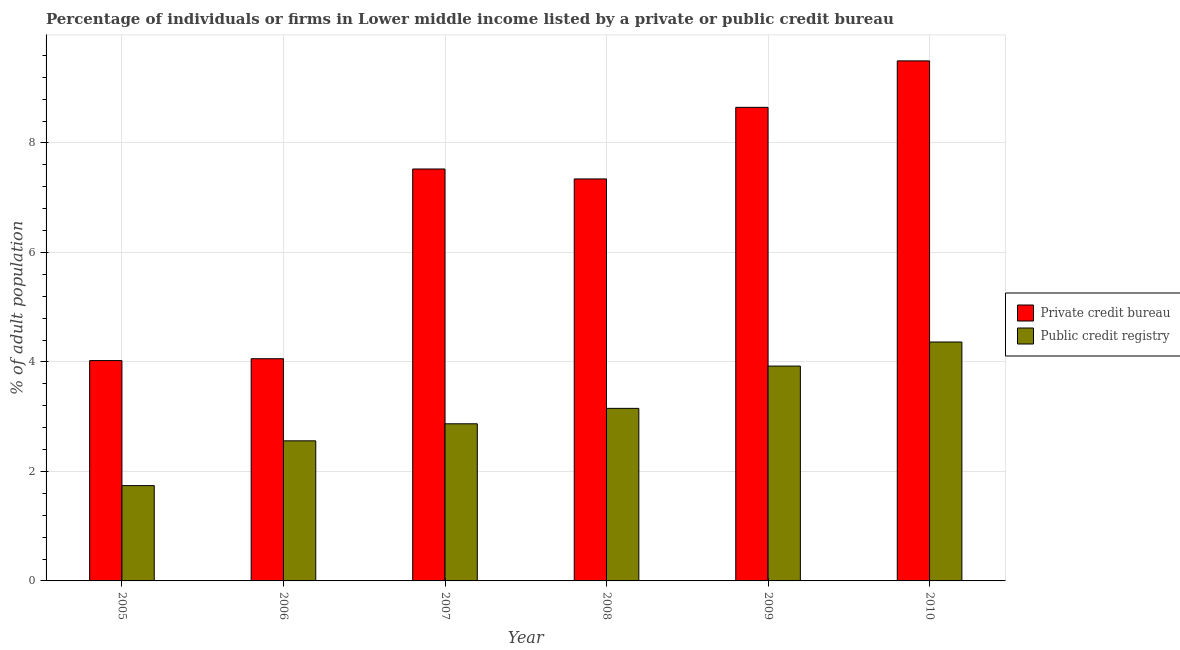How many different coloured bars are there?
Give a very brief answer. 2. How many groups of bars are there?
Your answer should be compact. 6. Are the number of bars per tick equal to the number of legend labels?
Keep it short and to the point. Yes. Are the number of bars on each tick of the X-axis equal?
Provide a succinct answer. Yes. How many bars are there on the 1st tick from the right?
Provide a succinct answer. 2. In how many cases, is the number of bars for a given year not equal to the number of legend labels?
Keep it short and to the point. 0. What is the percentage of firms listed by private credit bureau in 2009?
Your answer should be compact. 8.65. Across all years, what is the minimum percentage of firms listed by public credit bureau?
Provide a succinct answer. 1.74. In which year was the percentage of firms listed by public credit bureau minimum?
Offer a very short reply. 2005. What is the total percentage of firms listed by private credit bureau in the graph?
Provide a short and direct response. 41.1. What is the difference between the percentage of firms listed by private credit bureau in 2006 and that in 2009?
Offer a terse response. -4.59. What is the difference between the percentage of firms listed by private credit bureau in 2009 and the percentage of firms listed by public credit bureau in 2007?
Provide a short and direct response. 1.13. What is the average percentage of firms listed by public credit bureau per year?
Give a very brief answer. 3.1. What is the ratio of the percentage of firms listed by public credit bureau in 2005 to that in 2006?
Offer a terse response. 0.68. Is the percentage of firms listed by private credit bureau in 2005 less than that in 2010?
Keep it short and to the point. Yes. What is the difference between the highest and the second highest percentage of firms listed by private credit bureau?
Your response must be concise. 0.85. What is the difference between the highest and the lowest percentage of firms listed by private credit bureau?
Offer a very short reply. 5.47. Is the sum of the percentage of firms listed by public credit bureau in 2007 and 2008 greater than the maximum percentage of firms listed by private credit bureau across all years?
Offer a terse response. Yes. What does the 2nd bar from the left in 2008 represents?
Your answer should be very brief. Public credit registry. What does the 2nd bar from the right in 2009 represents?
Provide a short and direct response. Private credit bureau. How many bars are there?
Make the answer very short. 12. Are all the bars in the graph horizontal?
Provide a succinct answer. No. What is the difference between two consecutive major ticks on the Y-axis?
Provide a succinct answer. 2. Does the graph contain any zero values?
Offer a terse response. No. Where does the legend appear in the graph?
Your answer should be compact. Center right. How many legend labels are there?
Make the answer very short. 2. How are the legend labels stacked?
Provide a succinct answer. Vertical. What is the title of the graph?
Ensure brevity in your answer.  Percentage of individuals or firms in Lower middle income listed by a private or public credit bureau. What is the label or title of the X-axis?
Your answer should be very brief. Year. What is the label or title of the Y-axis?
Give a very brief answer. % of adult population. What is the % of adult population in Private credit bureau in 2005?
Make the answer very short. 4.03. What is the % of adult population in Public credit registry in 2005?
Your response must be concise. 1.74. What is the % of adult population of Private credit bureau in 2006?
Your answer should be very brief. 4.06. What is the % of adult population in Public credit registry in 2006?
Provide a succinct answer. 2.56. What is the % of adult population of Private credit bureau in 2007?
Provide a succinct answer. 7.53. What is the % of adult population of Public credit registry in 2007?
Offer a terse response. 2.87. What is the % of adult population of Private credit bureau in 2008?
Give a very brief answer. 7.34. What is the % of adult population in Public credit registry in 2008?
Offer a very short reply. 3.15. What is the % of adult population of Private credit bureau in 2009?
Make the answer very short. 8.65. What is the % of adult population in Public credit registry in 2009?
Your response must be concise. 3.92. What is the % of adult population of Private credit bureau in 2010?
Offer a very short reply. 9.5. What is the % of adult population of Public credit registry in 2010?
Give a very brief answer. 4.36. Across all years, what is the maximum % of adult population in Public credit registry?
Offer a very short reply. 4.36. Across all years, what is the minimum % of adult population in Private credit bureau?
Ensure brevity in your answer.  4.03. Across all years, what is the minimum % of adult population in Public credit registry?
Ensure brevity in your answer.  1.74. What is the total % of adult population in Private credit bureau in the graph?
Provide a short and direct response. 41.1. What is the total % of adult population in Public credit registry in the graph?
Your response must be concise. 18.61. What is the difference between the % of adult population in Private credit bureau in 2005 and that in 2006?
Your answer should be very brief. -0.03. What is the difference between the % of adult population in Public credit registry in 2005 and that in 2006?
Your response must be concise. -0.82. What is the difference between the % of adult population in Private credit bureau in 2005 and that in 2007?
Your response must be concise. -3.5. What is the difference between the % of adult population in Public credit registry in 2005 and that in 2007?
Provide a succinct answer. -1.13. What is the difference between the % of adult population of Private credit bureau in 2005 and that in 2008?
Offer a terse response. -3.32. What is the difference between the % of adult population in Public credit registry in 2005 and that in 2008?
Make the answer very short. -1.41. What is the difference between the % of adult population of Private credit bureau in 2005 and that in 2009?
Provide a short and direct response. -4.63. What is the difference between the % of adult population in Public credit registry in 2005 and that in 2009?
Offer a terse response. -2.18. What is the difference between the % of adult population in Private credit bureau in 2005 and that in 2010?
Ensure brevity in your answer.  -5.47. What is the difference between the % of adult population of Public credit registry in 2005 and that in 2010?
Your answer should be compact. -2.62. What is the difference between the % of adult population in Private credit bureau in 2006 and that in 2007?
Your answer should be very brief. -3.47. What is the difference between the % of adult population of Public credit registry in 2006 and that in 2007?
Offer a terse response. -0.31. What is the difference between the % of adult population in Private credit bureau in 2006 and that in 2008?
Your answer should be very brief. -3.28. What is the difference between the % of adult population of Public credit registry in 2006 and that in 2008?
Your response must be concise. -0.59. What is the difference between the % of adult population in Private credit bureau in 2006 and that in 2009?
Your answer should be very brief. -4.59. What is the difference between the % of adult population in Public credit registry in 2006 and that in 2009?
Your answer should be compact. -1.37. What is the difference between the % of adult population of Private credit bureau in 2006 and that in 2010?
Provide a succinct answer. -5.44. What is the difference between the % of adult population of Public credit registry in 2006 and that in 2010?
Make the answer very short. -1.81. What is the difference between the % of adult population in Private credit bureau in 2007 and that in 2008?
Ensure brevity in your answer.  0.18. What is the difference between the % of adult population in Public credit registry in 2007 and that in 2008?
Make the answer very short. -0.28. What is the difference between the % of adult population in Private credit bureau in 2007 and that in 2009?
Provide a short and direct response. -1.13. What is the difference between the % of adult population in Public credit registry in 2007 and that in 2009?
Make the answer very short. -1.05. What is the difference between the % of adult population in Private credit bureau in 2007 and that in 2010?
Ensure brevity in your answer.  -1.98. What is the difference between the % of adult population of Public credit registry in 2007 and that in 2010?
Ensure brevity in your answer.  -1.49. What is the difference between the % of adult population in Private credit bureau in 2008 and that in 2009?
Your response must be concise. -1.31. What is the difference between the % of adult population in Public credit registry in 2008 and that in 2009?
Offer a very short reply. -0.77. What is the difference between the % of adult population in Private credit bureau in 2008 and that in 2010?
Make the answer very short. -2.16. What is the difference between the % of adult population in Public credit registry in 2008 and that in 2010?
Offer a very short reply. -1.21. What is the difference between the % of adult population in Private credit bureau in 2009 and that in 2010?
Make the answer very short. -0.85. What is the difference between the % of adult population in Public credit registry in 2009 and that in 2010?
Your answer should be very brief. -0.44. What is the difference between the % of adult population in Private credit bureau in 2005 and the % of adult population in Public credit registry in 2006?
Your answer should be very brief. 1.47. What is the difference between the % of adult population in Private credit bureau in 2005 and the % of adult population in Public credit registry in 2007?
Provide a succinct answer. 1.15. What is the difference between the % of adult population of Private credit bureau in 2005 and the % of adult population of Public credit registry in 2008?
Provide a succinct answer. 0.87. What is the difference between the % of adult population of Private credit bureau in 2005 and the % of adult population of Public credit registry in 2009?
Your answer should be very brief. 0.1. What is the difference between the % of adult population in Private credit bureau in 2005 and the % of adult population in Public credit registry in 2010?
Your answer should be very brief. -0.34. What is the difference between the % of adult population of Private credit bureau in 2006 and the % of adult population of Public credit registry in 2007?
Provide a short and direct response. 1.19. What is the difference between the % of adult population in Private credit bureau in 2006 and the % of adult population in Public credit registry in 2008?
Your answer should be very brief. 0.91. What is the difference between the % of adult population in Private credit bureau in 2006 and the % of adult population in Public credit registry in 2009?
Keep it short and to the point. 0.13. What is the difference between the % of adult population of Private credit bureau in 2006 and the % of adult population of Public credit registry in 2010?
Make the answer very short. -0.31. What is the difference between the % of adult population of Private credit bureau in 2007 and the % of adult population of Public credit registry in 2008?
Your answer should be very brief. 4.37. What is the difference between the % of adult population of Private credit bureau in 2007 and the % of adult population of Public credit registry in 2009?
Provide a short and direct response. 3.6. What is the difference between the % of adult population in Private credit bureau in 2007 and the % of adult population in Public credit registry in 2010?
Ensure brevity in your answer.  3.16. What is the difference between the % of adult population of Private credit bureau in 2008 and the % of adult population of Public credit registry in 2009?
Give a very brief answer. 3.42. What is the difference between the % of adult population of Private credit bureau in 2008 and the % of adult population of Public credit registry in 2010?
Provide a short and direct response. 2.98. What is the difference between the % of adult population in Private credit bureau in 2009 and the % of adult population in Public credit registry in 2010?
Make the answer very short. 4.29. What is the average % of adult population of Private credit bureau per year?
Make the answer very short. 6.85. What is the average % of adult population in Public credit registry per year?
Your answer should be compact. 3.1. In the year 2005, what is the difference between the % of adult population of Private credit bureau and % of adult population of Public credit registry?
Give a very brief answer. 2.28. In the year 2006, what is the difference between the % of adult population in Private credit bureau and % of adult population in Public credit registry?
Ensure brevity in your answer.  1.5. In the year 2007, what is the difference between the % of adult population of Private credit bureau and % of adult population of Public credit registry?
Give a very brief answer. 4.65. In the year 2008, what is the difference between the % of adult population in Private credit bureau and % of adult population in Public credit registry?
Give a very brief answer. 4.19. In the year 2009, what is the difference between the % of adult population of Private credit bureau and % of adult population of Public credit registry?
Give a very brief answer. 4.73. In the year 2010, what is the difference between the % of adult population of Private credit bureau and % of adult population of Public credit registry?
Your answer should be compact. 5.14. What is the ratio of the % of adult population of Private credit bureau in 2005 to that in 2006?
Provide a succinct answer. 0.99. What is the ratio of the % of adult population of Public credit registry in 2005 to that in 2006?
Make the answer very short. 0.68. What is the ratio of the % of adult population in Private credit bureau in 2005 to that in 2007?
Give a very brief answer. 0.53. What is the ratio of the % of adult population in Public credit registry in 2005 to that in 2007?
Your response must be concise. 0.61. What is the ratio of the % of adult population of Private credit bureau in 2005 to that in 2008?
Your answer should be compact. 0.55. What is the ratio of the % of adult population in Public credit registry in 2005 to that in 2008?
Provide a short and direct response. 0.55. What is the ratio of the % of adult population of Private credit bureau in 2005 to that in 2009?
Ensure brevity in your answer.  0.47. What is the ratio of the % of adult population in Public credit registry in 2005 to that in 2009?
Give a very brief answer. 0.44. What is the ratio of the % of adult population in Private credit bureau in 2005 to that in 2010?
Keep it short and to the point. 0.42. What is the ratio of the % of adult population of Public credit registry in 2005 to that in 2010?
Offer a terse response. 0.4. What is the ratio of the % of adult population of Private credit bureau in 2006 to that in 2007?
Ensure brevity in your answer.  0.54. What is the ratio of the % of adult population in Public credit registry in 2006 to that in 2007?
Provide a succinct answer. 0.89. What is the ratio of the % of adult population of Private credit bureau in 2006 to that in 2008?
Ensure brevity in your answer.  0.55. What is the ratio of the % of adult population in Public credit registry in 2006 to that in 2008?
Keep it short and to the point. 0.81. What is the ratio of the % of adult population of Private credit bureau in 2006 to that in 2009?
Your answer should be compact. 0.47. What is the ratio of the % of adult population of Public credit registry in 2006 to that in 2009?
Provide a succinct answer. 0.65. What is the ratio of the % of adult population of Private credit bureau in 2006 to that in 2010?
Your answer should be very brief. 0.43. What is the ratio of the % of adult population in Public credit registry in 2006 to that in 2010?
Make the answer very short. 0.59. What is the ratio of the % of adult population of Private credit bureau in 2007 to that in 2008?
Keep it short and to the point. 1.02. What is the ratio of the % of adult population of Public credit registry in 2007 to that in 2008?
Your answer should be very brief. 0.91. What is the ratio of the % of adult population in Private credit bureau in 2007 to that in 2009?
Provide a succinct answer. 0.87. What is the ratio of the % of adult population of Public credit registry in 2007 to that in 2009?
Keep it short and to the point. 0.73. What is the ratio of the % of adult population in Private credit bureau in 2007 to that in 2010?
Provide a succinct answer. 0.79. What is the ratio of the % of adult population of Public credit registry in 2007 to that in 2010?
Make the answer very short. 0.66. What is the ratio of the % of adult population of Private credit bureau in 2008 to that in 2009?
Provide a succinct answer. 0.85. What is the ratio of the % of adult population of Public credit registry in 2008 to that in 2009?
Provide a short and direct response. 0.8. What is the ratio of the % of adult population of Private credit bureau in 2008 to that in 2010?
Your answer should be very brief. 0.77. What is the ratio of the % of adult population in Public credit registry in 2008 to that in 2010?
Give a very brief answer. 0.72. What is the ratio of the % of adult population in Private credit bureau in 2009 to that in 2010?
Offer a terse response. 0.91. What is the ratio of the % of adult population of Public credit registry in 2009 to that in 2010?
Provide a short and direct response. 0.9. What is the difference between the highest and the second highest % of adult population of Private credit bureau?
Make the answer very short. 0.85. What is the difference between the highest and the second highest % of adult population in Public credit registry?
Offer a terse response. 0.44. What is the difference between the highest and the lowest % of adult population of Private credit bureau?
Your response must be concise. 5.47. What is the difference between the highest and the lowest % of adult population in Public credit registry?
Your answer should be compact. 2.62. 